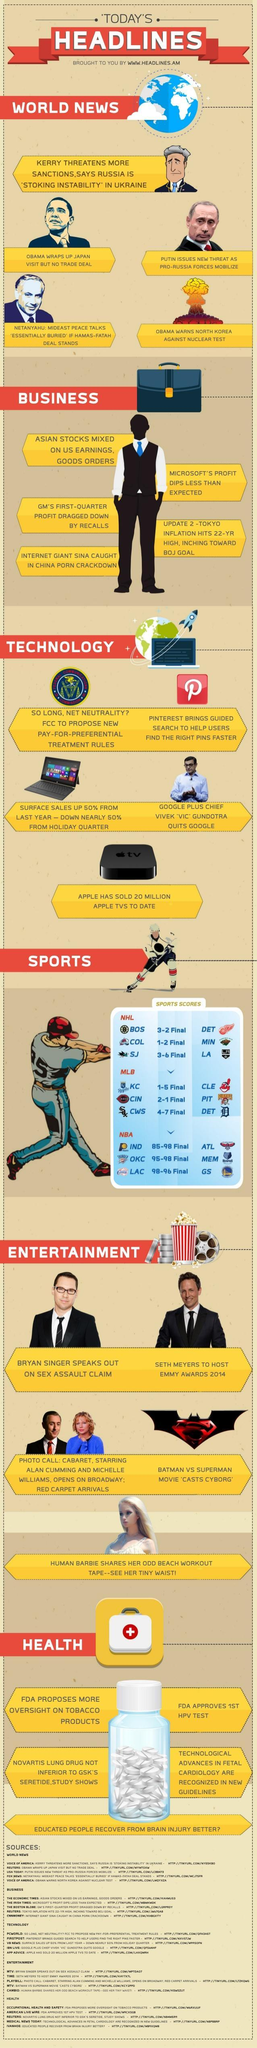How many news under the heading world news?
Answer the question with a short phrase. 5 How many headlines are in this infographic? 6 How many news under the heading business? 5 How many news under the heading technology? 5 How many types of games under the heading sports? 3 